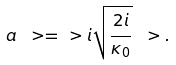<formula> <loc_0><loc_0><loc_500><loc_500>a \ > = \ > i \sqrt { \frac { 2 i } { \kappa _ { 0 } } } \ > .</formula> 